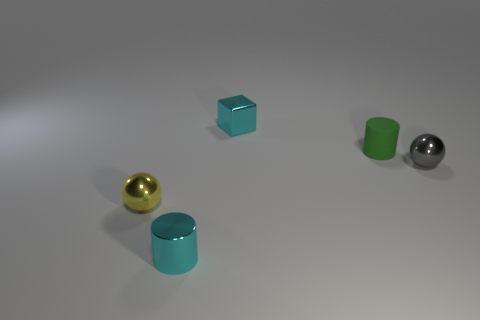Is there anything else that is the same size as the cyan shiny cube?
Ensure brevity in your answer.  Yes. There is a thing that is the same color as the small cube; what size is it?
Give a very brief answer. Small. How many red things are either tiny matte things or tiny balls?
Your answer should be very brief. 0. Are there any small metal cylinders of the same color as the rubber object?
Provide a short and direct response. No. Are there any cyan cylinders that have the same material as the tiny yellow thing?
Your response must be concise. Yes. What is the shape of the metallic object that is behind the small yellow metal sphere and in front of the metal cube?
Ensure brevity in your answer.  Sphere. What number of tiny objects are either yellow spheres or cyan rubber balls?
Offer a terse response. 1. What is the small green cylinder made of?
Keep it short and to the point. Rubber. The metallic cylinder has what size?
Your answer should be very brief. Small. What size is the object that is both in front of the cyan metallic block and behind the small gray sphere?
Your response must be concise. Small. 